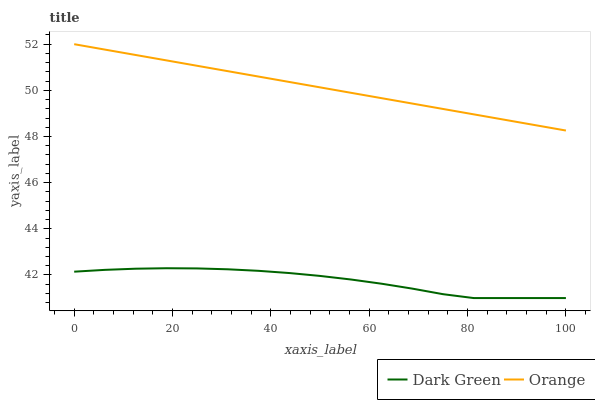Does Dark Green have the minimum area under the curve?
Answer yes or no. Yes. Does Orange have the maximum area under the curve?
Answer yes or no. Yes. Does Dark Green have the maximum area under the curve?
Answer yes or no. No. Is Orange the smoothest?
Answer yes or no. Yes. Is Dark Green the roughest?
Answer yes or no. Yes. Is Dark Green the smoothest?
Answer yes or no. No. Does Dark Green have the lowest value?
Answer yes or no. Yes. Does Orange have the highest value?
Answer yes or no. Yes. Does Dark Green have the highest value?
Answer yes or no. No. Is Dark Green less than Orange?
Answer yes or no. Yes. Is Orange greater than Dark Green?
Answer yes or no. Yes. Does Dark Green intersect Orange?
Answer yes or no. No. 